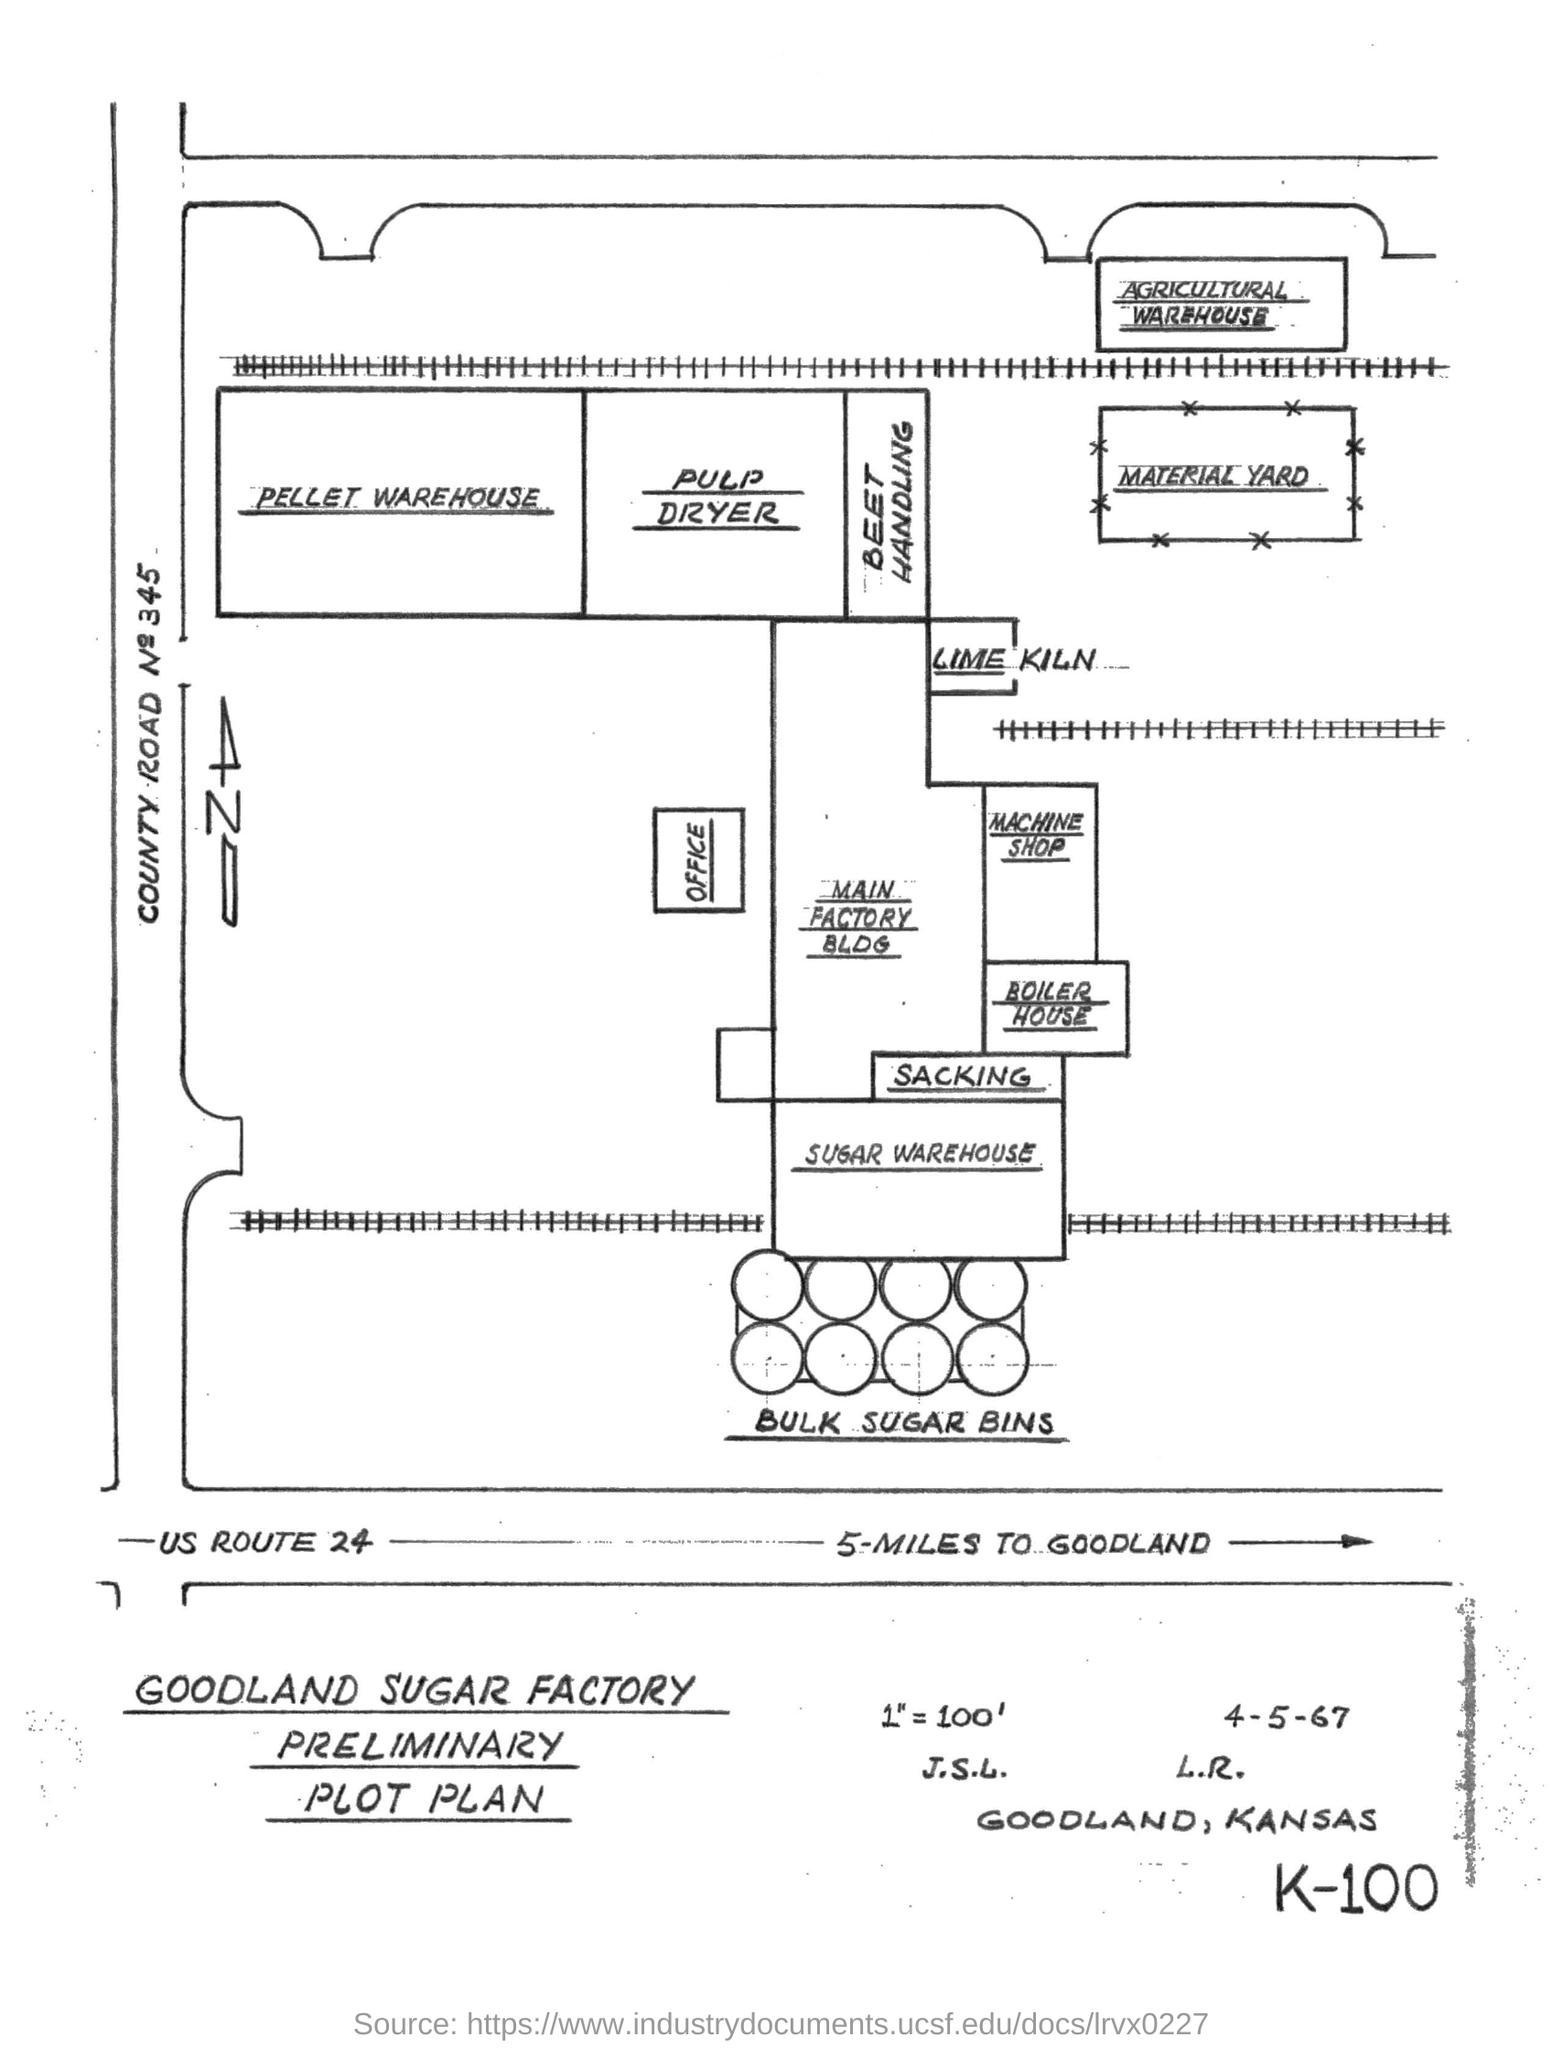This is the Preliminary Plot Plan of which Factory ?
Your answer should be compact. GoodLand Sugar Factory. How many miles to GoodLand in US ROUTE 24 ?
Give a very brief answer. 5-MILES. What is the cabin after Bulk Sugar Bins ?
Your answer should be compact. SUGAR WAREHOUSE. 345 is the Number of which road ?
Keep it short and to the point. County Road. 